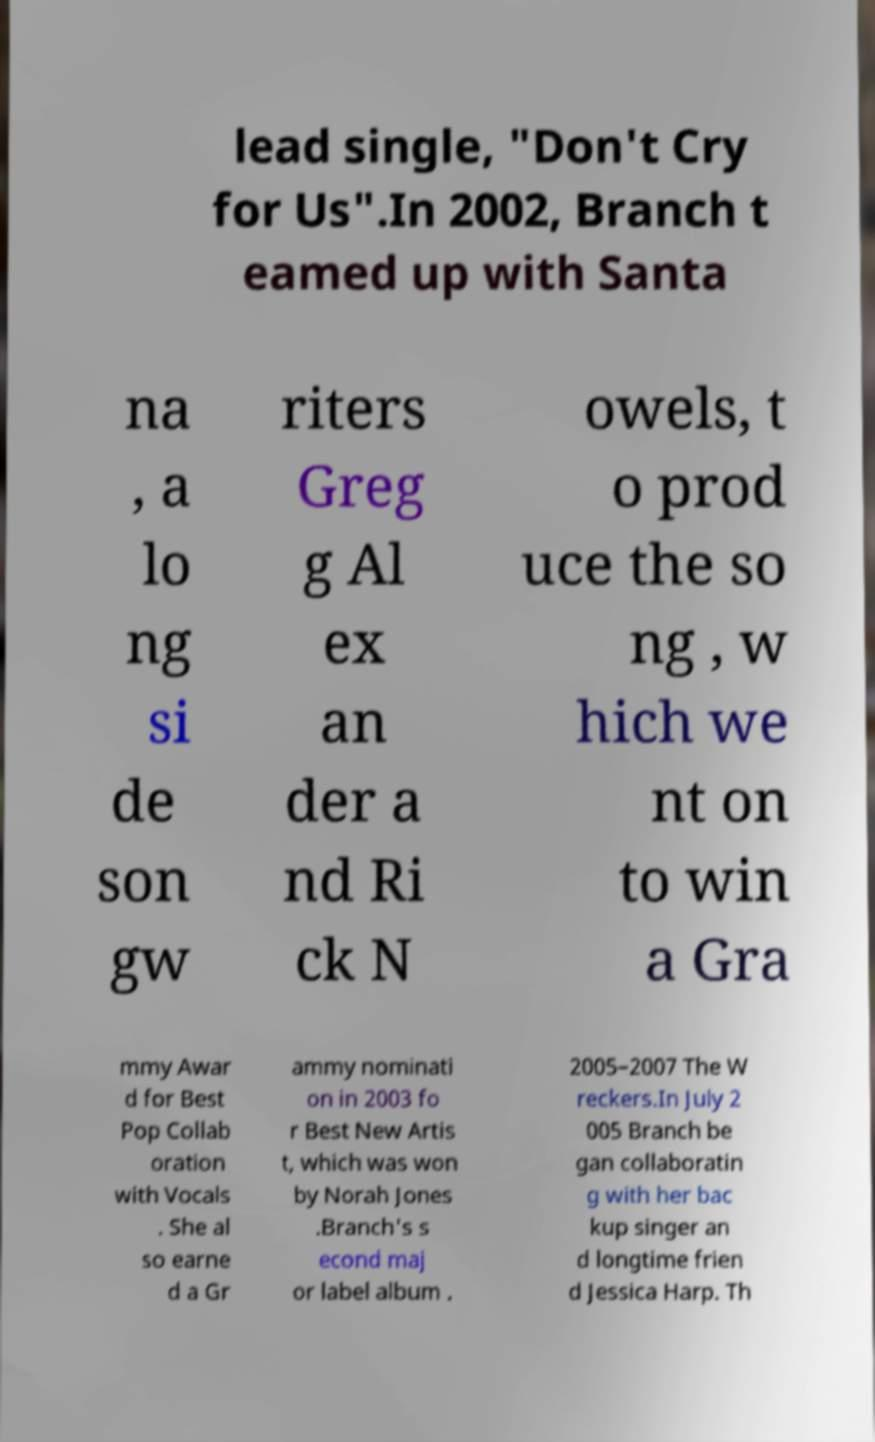There's text embedded in this image that I need extracted. Can you transcribe it verbatim? lead single, "Don't Cry for Us".In 2002, Branch t eamed up with Santa na , a lo ng si de son gw riters Greg g Al ex an der a nd Ri ck N owels, t o prod uce the so ng , w hich we nt on to win a Gra mmy Awar d for Best Pop Collab oration with Vocals . She al so earne d a Gr ammy nominati on in 2003 fo r Best New Artis t, which was won by Norah Jones .Branch's s econd maj or label album . 2005–2007 The W reckers.In July 2 005 Branch be gan collaboratin g with her bac kup singer an d longtime frien d Jessica Harp. Th 